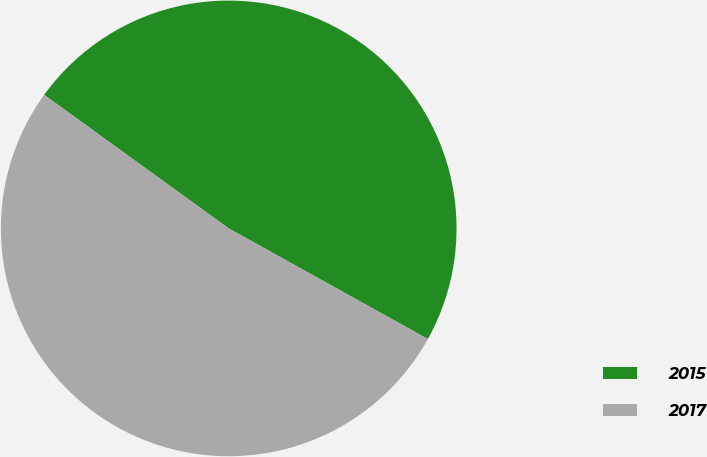Convert chart. <chart><loc_0><loc_0><loc_500><loc_500><pie_chart><fcel>2015<fcel>2017<nl><fcel>48.1%<fcel>51.9%<nl></chart> 